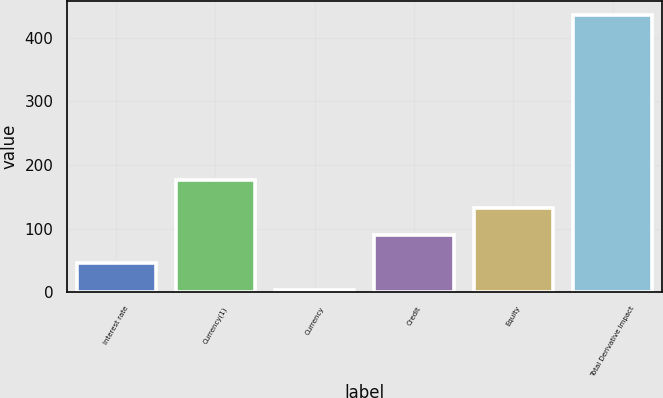Convert chart. <chart><loc_0><loc_0><loc_500><loc_500><bar_chart><fcel>Interest rate<fcel>Currency(1)<fcel>Currency<fcel>Credit<fcel>Equity<fcel>Total Derivative Impact<nl><fcel>46.3<fcel>176.2<fcel>3<fcel>89.6<fcel>132.9<fcel>436<nl></chart> 